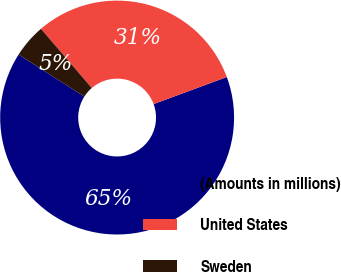Convert chart. <chart><loc_0><loc_0><loc_500><loc_500><pie_chart><fcel>(Amounts in millions)<fcel>United States<fcel>Sweden<nl><fcel>64.68%<fcel>30.65%<fcel>4.66%<nl></chart> 